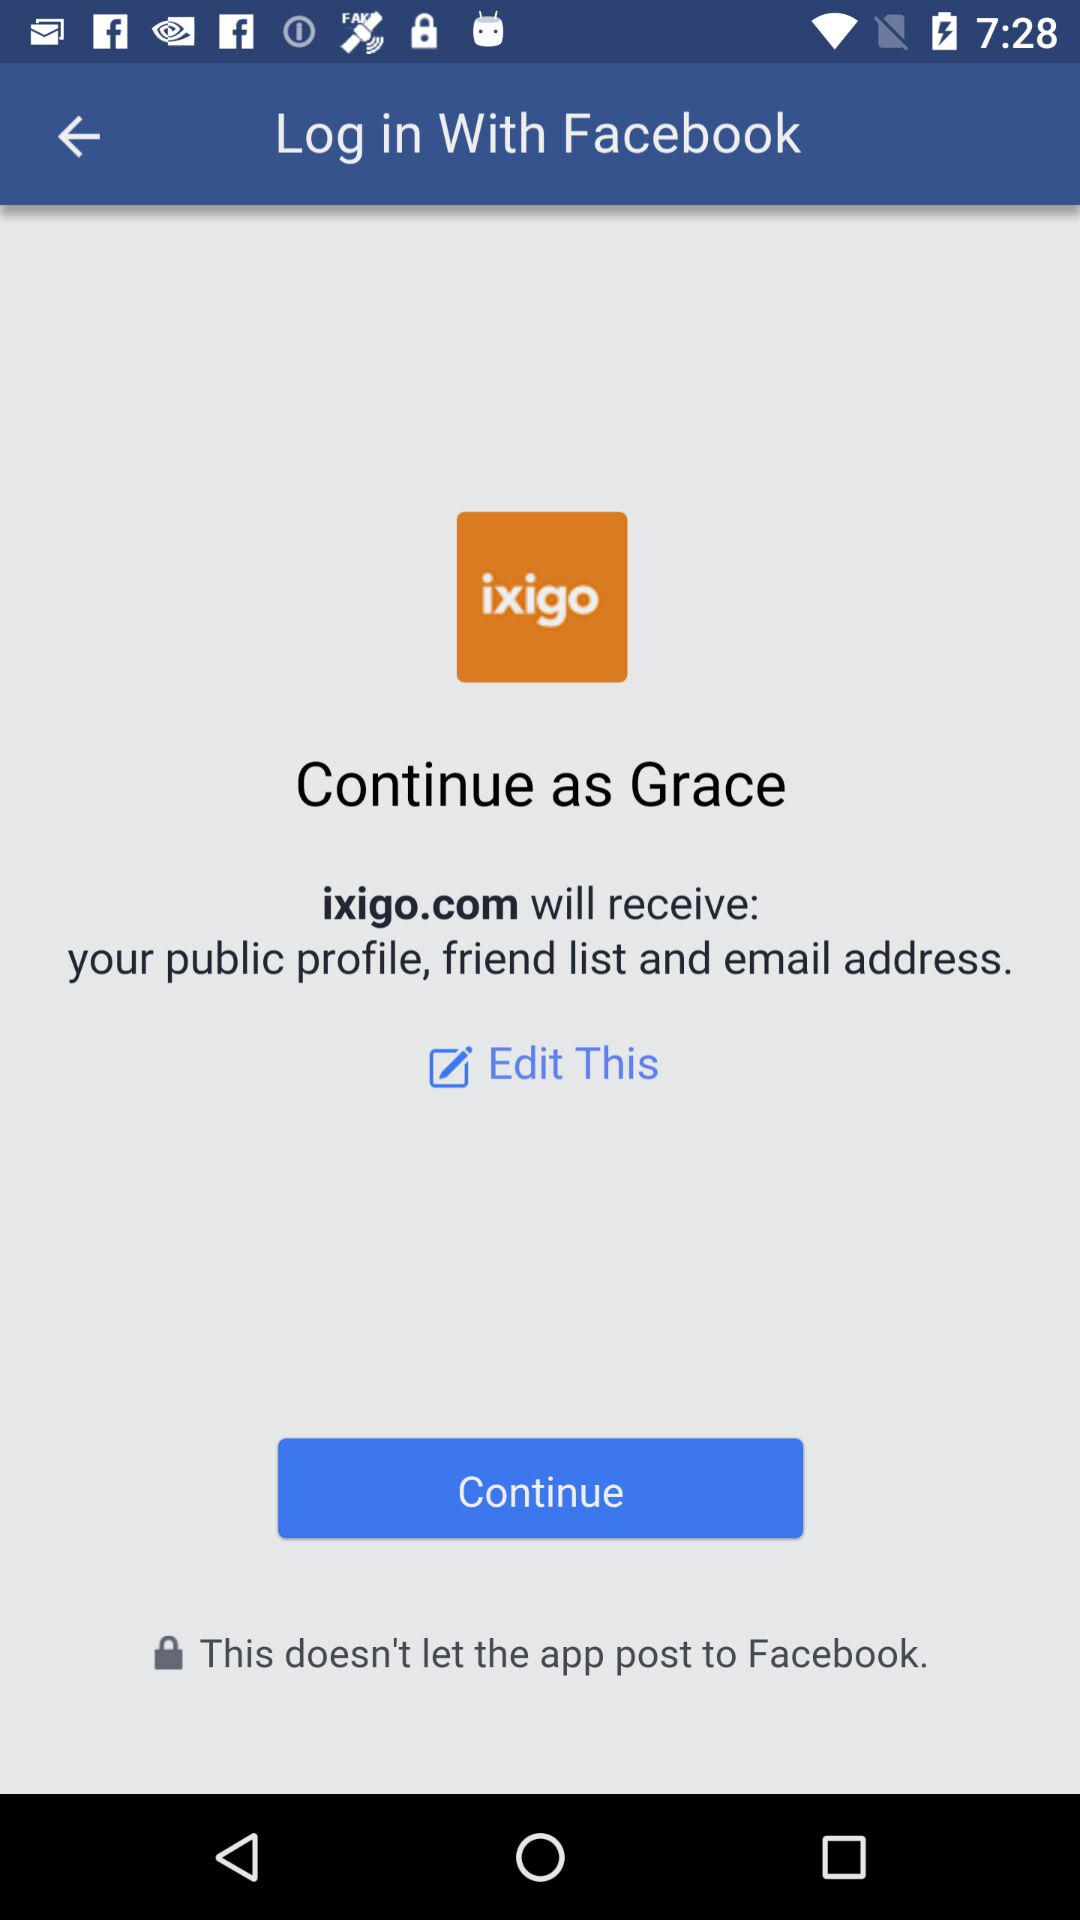What application is used for login? The application used is "Facebook". 